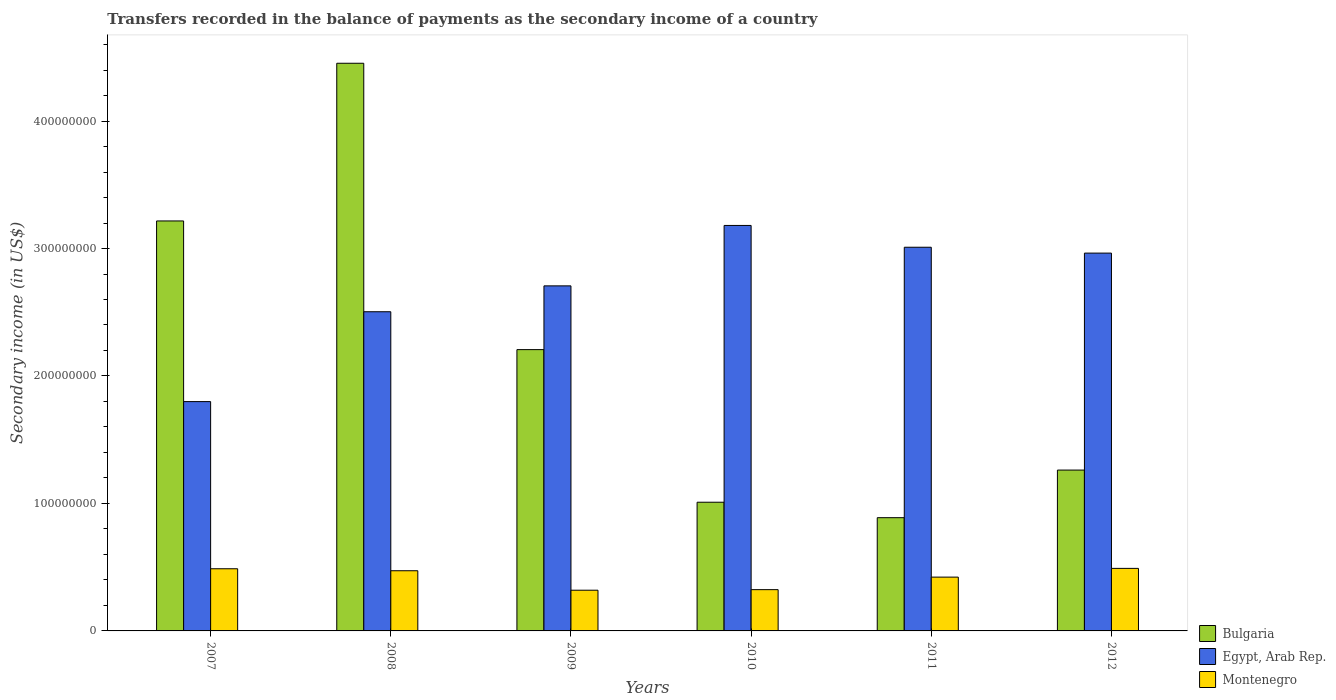How many groups of bars are there?
Provide a short and direct response. 6. Are the number of bars per tick equal to the number of legend labels?
Offer a terse response. Yes. In how many cases, is the number of bars for a given year not equal to the number of legend labels?
Keep it short and to the point. 0. What is the secondary income of in Bulgaria in 2010?
Ensure brevity in your answer.  1.01e+08. Across all years, what is the maximum secondary income of in Montenegro?
Offer a terse response. 4.91e+07. Across all years, what is the minimum secondary income of in Montenegro?
Your answer should be very brief. 3.19e+07. In which year was the secondary income of in Montenegro maximum?
Your answer should be very brief. 2012. In which year was the secondary income of in Montenegro minimum?
Provide a short and direct response. 2009. What is the total secondary income of in Montenegro in the graph?
Your answer should be compact. 2.52e+08. What is the difference between the secondary income of in Montenegro in 2010 and that in 2011?
Keep it short and to the point. -9.83e+06. What is the difference between the secondary income of in Bulgaria in 2007 and the secondary income of in Montenegro in 2010?
Offer a terse response. 2.89e+08. What is the average secondary income of in Egypt, Arab Rep. per year?
Provide a short and direct response. 2.69e+08. In the year 2008, what is the difference between the secondary income of in Egypt, Arab Rep. and secondary income of in Montenegro?
Offer a terse response. 2.03e+08. In how many years, is the secondary income of in Bulgaria greater than 140000000 US$?
Give a very brief answer. 3. What is the ratio of the secondary income of in Egypt, Arab Rep. in 2010 to that in 2011?
Give a very brief answer. 1.06. Is the difference between the secondary income of in Egypt, Arab Rep. in 2008 and 2011 greater than the difference between the secondary income of in Montenegro in 2008 and 2011?
Keep it short and to the point. No. What is the difference between the highest and the second highest secondary income of in Bulgaria?
Ensure brevity in your answer.  1.24e+08. What is the difference between the highest and the lowest secondary income of in Montenegro?
Offer a terse response. 1.71e+07. How many years are there in the graph?
Your answer should be very brief. 6. What is the difference between two consecutive major ticks on the Y-axis?
Your answer should be compact. 1.00e+08. Are the values on the major ticks of Y-axis written in scientific E-notation?
Provide a short and direct response. No. Does the graph contain any zero values?
Offer a terse response. No. Does the graph contain grids?
Your response must be concise. No. Where does the legend appear in the graph?
Your response must be concise. Bottom right. How many legend labels are there?
Provide a succinct answer. 3. What is the title of the graph?
Your response must be concise. Transfers recorded in the balance of payments as the secondary income of a country. What is the label or title of the Y-axis?
Offer a very short reply. Secondary income (in US$). What is the Secondary income (in US$) of Bulgaria in 2007?
Make the answer very short. 3.22e+08. What is the Secondary income (in US$) of Egypt, Arab Rep. in 2007?
Offer a very short reply. 1.80e+08. What is the Secondary income (in US$) of Montenegro in 2007?
Your answer should be compact. 4.88e+07. What is the Secondary income (in US$) of Bulgaria in 2008?
Your response must be concise. 4.45e+08. What is the Secondary income (in US$) of Egypt, Arab Rep. in 2008?
Offer a terse response. 2.50e+08. What is the Secondary income (in US$) of Montenegro in 2008?
Your answer should be compact. 4.72e+07. What is the Secondary income (in US$) of Bulgaria in 2009?
Keep it short and to the point. 2.21e+08. What is the Secondary income (in US$) of Egypt, Arab Rep. in 2009?
Keep it short and to the point. 2.71e+08. What is the Secondary income (in US$) in Montenegro in 2009?
Your response must be concise. 3.19e+07. What is the Secondary income (in US$) of Bulgaria in 2010?
Give a very brief answer. 1.01e+08. What is the Secondary income (in US$) in Egypt, Arab Rep. in 2010?
Keep it short and to the point. 3.18e+08. What is the Secondary income (in US$) in Montenegro in 2010?
Your response must be concise. 3.24e+07. What is the Secondary income (in US$) of Bulgaria in 2011?
Offer a very short reply. 8.88e+07. What is the Secondary income (in US$) in Egypt, Arab Rep. in 2011?
Provide a short and direct response. 3.01e+08. What is the Secondary income (in US$) of Montenegro in 2011?
Give a very brief answer. 4.22e+07. What is the Secondary income (in US$) of Bulgaria in 2012?
Give a very brief answer. 1.26e+08. What is the Secondary income (in US$) of Egypt, Arab Rep. in 2012?
Your answer should be compact. 2.96e+08. What is the Secondary income (in US$) in Montenegro in 2012?
Your answer should be very brief. 4.91e+07. Across all years, what is the maximum Secondary income (in US$) of Bulgaria?
Your answer should be compact. 4.45e+08. Across all years, what is the maximum Secondary income (in US$) of Egypt, Arab Rep.?
Make the answer very short. 3.18e+08. Across all years, what is the maximum Secondary income (in US$) in Montenegro?
Make the answer very short. 4.91e+07. Across all years, what is the minimum Secondary income (in US$) of Bulgaria?
Offer a very short reply. 8.88e+07. Across all years, what is the minimum Secondary income (in US$) in Egypt, Arab Rep.?
Make the answer very short. 1.80e+08. Across all years, what is the minimum Secondary income (in US$) in Montenegro?
Provide a succinct answer. 3.19e+07. What is the total Secondary income (in US$) of Bulgaria in the graph?
Ensure brevity in your answer.  1.30e+09. What is the total Secondary income (in US$) in Egypt, Arab Rep. in the graph?
Keep it short and to the point. 1.62e+09. What is the total Secondary income (in US$) of Montenegro in the graph?
Ensure brevity in your answer.  2.52e+08. What is the difference between the Secondary income (in US$) of Bulgaria in 2007 and that in 2008?
Ensure brevity in your answer.  -1.24e+08. What is the difference between the Secondary income (in US$) of Egypt, Arab Rep. in 2007 and that in 2008?
Make the answer very short. -7.05e+07. What is the difference between the Secondary income (in US$) in Montenegro in 2007 and that in 2008?
Your answer should be very brief. 1.56e+06. What is the difference between the Secondary income (in US$) of Bulgaria in 2007 and that in 2009?
Provide a succinct answer. 1.01e+08. What is the difference between the Secondary income (in US$) of Egypt, Arab Rep. in 2007 and that in 2009?
Your response must be concise. -9.08e+07. What is the difference between the Secondary income (in US$) in Montenegro in 2007 and that in 2009?
Offer a terse response. 1.68e+07. What is the difference between the Secondary income (in US$) of Bulgaria in 2007 and that in 2010?
Offer a very short reply. 2.21e+08. What is the difference between the Secondary income (in US$) in Egypt, Arab Rep. in 2007 and that in 2010?
Keep it short and to the point. -1.38e+08. What is the difference between the Secondary income (in US$) of Montenegro in 2007 and that in 2010?
Offer a very short reply. 1.64e+07. What is the difference between the Secondary income (in US$) in Bulgaria in 2007 and that in 2011?
Offer a very short reply. 2.33e+08. What is the difference between the Secondary income (in US$) of Egypt, Arab Rep. in 2007 and that in 2011?
Offer a very short reply. -1.21e+08. What is the difference between the Secondary income (in US$) of Montenegro in 2007 and that in 2011?
Your answer should be compact. 6.56e+06. What is the difference between the Secondary income (in US$) of Bulgaria in 2007 and that in 2012?
Offer a terse response. 1.95e+08. What is the difference between the Secondary income (in US$) of Egypt, Arab Rep. in 2007 and that in 2012?
Provide a succinct answer. -1.16e+08. What is the difference between the Secondary income (in US$) of Montenegro in 2007 and that in 2012?
Make the answer very short. -2.88e+05. What is the difference between the Secondary income (in US$) in Bulgaria in 2008 and that in 2009?
Offer a terse response. 2.25e+08. What is the difference between the Secondary income (in US$) in Egypt, Arab Rep. in 2008 and that in 2009?
Keep it short and to the point. -2.03e+07. What is the difference between the Secondary income (in US$) of Montenegro in 2008 and that in 2009?
Give a very brief answer. 1.53e+07. What is the difference between the Secondary income (in US$) in Bulgaria in 2008 and that in 2010?
Make the answer very short. 3.44e+08. What is the difference between the Secondary income (in US$) of Egypt, Arab Rep. in 2008 and that in 2010?
Ensure brevity in your answer.  -6.77e+07. What is the difference between the Secondary income (in US$) of Montenegro in 2008 and that in 2010?
Your answer should be compact. 1.48e+07. What is the difference between the Secondary income (in US$) in Bulgaria in 2008 and that in 2011?
Offer a terse response. 3.56e+08. What is the difference between the Secondary income (in US$) in Egypt, Arab Rep. in 2008 and that in 2011?
Keep it short and to the point. -5.06e+07. What is the difference between the Secondary income (in US$) of Montenegro in 2008 and that in 2011?
Provide a succinct answer. 5.01e+06. What is the difference between the Secondary income (in US$) of Bulgaria in 2008 and that in 2012?
Offer a terse response. 3.19e+08. What is the difference between the Secondary income (in US$) of Egypt, Arab Rep. in 2008 and that in 2012?
Give a very brief answer. -4.60e+07. What is the difference between the Secondary income (in US$) of Montenegro in 2008 and that in 2012?
Give a very brief answer. -1.84e+06. What is the difference between the Secondary income (in US$) in Bulgaria in 2009 and that in 2010?
Provide a short and direct response. 1.20e+08. What is the difference between the Secondary income (in US$) in Egypt, Arab Rep. in 2009 and that in 2010?
Make the answer very short. -4.74e+07. What is the difference between the Secondary income (in US$) in Montenegro in 2009 and that in 2010?
Your answer should be compact. -4.32e+05. What is the difference between the Secondary income (in US$) in Bulgaria in 2009 and that in 2011?
Offer a terse response. 1.32e+08. What is the difference between the Secondary income (in US$) of Egypt, Arab Rep. in 2009 and that in 2011?
Your answer should be very brief. -3.03e+07. What is the difference between the Secondary income (in US$) of Montenegro in 2009 and that in 2011?
Ensure brevity in your answer.  -1.03e+07. What is the difference between the Secondary income (in US$) in Bulgaria in 2009 and that in 2012?
Your response must be concise. 9.45e+07. What is the difference between the Secondary income (in US$) in Egypt, Arab Rep. in 2009 and that in 2012?
Give a very brief answer. -2.57e+07. What is the difference between the Secondary income (in US$) in Montenegro in 2009 and that in 2012?
Ensure brevity in your answer.  -1.71e+07. What is the difference between the Secondary income (in US$) in Bulgaria in 2010 and that in 2011?
Provide a short and direct response. 1.21e+07. What is the difference between the Secondary income (in US$) of Egypt, Arab Rep. in 2010 and that in 2011?
Make the answer very short. 1.71e+07. What is the difference between the Secondary income (in US$) in Montenegro in 2010 and that in 2011?
Your answer should be compact. -9.83e+06. What is the difference between the Secondary income (in US$) in Bulgaria in 2010 and that in 2012?
Your answer should be very brief. -2.52e+07. What is the difference between the Secondary income (in US$) in Egypt, Arab Rep. in 2010 and that in 2012?
Give a very brief answer. 2.17e+07. What is the difference between the Secondary income (in US$) of Montenegro in 2010 and that in 2012?
Make the answer very short. -1.67e+07. What is the difference between the Secondary income (in US$) of Bulgaria in 2011 and that in 2012?
Give a very brief answer. -3.73e+07. What is the difference between the Secondary income (in US$) of Egypt, Arab Rep. in 2011 and that in 2012?
Your answer should be very brief. 4.60e+06. What is the difference between the Secondary income (in US$) in Montenegro in 2011 and that in 2012?
Give a very brief answer. -6.85e+06. What is the difference between the Secondary income (in US$) of Bulgaria in 2007 and the Secondary income (in US$) of Egypt, Arab Rep. in 2008?
Give a very brief answer. 7.12e+07. What is the difference between the Secondary income (in US$) of Bulgaria in 2007 and the Secondary income (in US$) of Montenegro in 2008?
Provide a short and direct response. 2.74e+08. What is the difference between the Secondary income (in US$) in Egypt, Arab Rep. in 2007 and the Secondary income (in US$) in Montenegro in 2008?
Ensure brevity in your answer.  1.33e+08. What is the difference between the Secondary income (in US$) in Bulgaria in 2007 and the Secondary income (in US$) in Egypt, Arab Rep. in 2009?
Give a very brief answer. 5.09e+07. What is the difference between the Secondary income (in US$) in Bulgaria in 2007 and the Secondary income (in US$) in Montenegro in 2009?
Offer a terse response. 2.90e+08. What is the difference between the Secondary income (in US$) of Egypt, Arab Rep. in 2007 and the Secondary income (in US$) of Montenegro in 2009?
Ensure brevity in your answer.  1.48e+08. What is the difference between the Secondary income (in US$) of Bulgaria in 2007 and the Secondary income (in US$) of Egypt, Arab Rep. in 2010?
Give a very brief answer. 3.53e+06. What is the difference between the Secondary income (in US$) of Bulgaria in 2007 and the Secondary income (in US$) of Montenegro in 2010?
Your answer should be very brief. 2.89e+08. What is the difference between the Secondary income (in US$) in Egypt, Arab Rep. in 2007 and the Secondary income (in US$) in Montenegro in 2010?
Your answer should be compact. 1.48e+08. What is the difference between the Secondary income (in US$) in Bulgaria in 2007 and the Secondary income (in US$) in Egypt, Arab Rep. in 2011?
Offer a very short reply. 2.06e+07. What is the difference between the Secondary income (in US$) of Bulgaria in 2007 and the Secondary income (in US$) of Montenegro in 2011?
Offer a terse response. 2.79e+08. What is the difference between the Secondary income (in US$) in Egypt, Arab Rep. in 2007 and the Secondary income (in US$) in Montenegro in 2011?
Offer a terse response. 1.38e+08. What is the difference between the Secondary income (in US$) in Bulgaria in 2007 and the Secondary income (in US$) in Egypt, Arab Rep. in 2012?
Your answer should be very brief. 2.52e+07. What is the difference between the Secondary income (in US$) in Bulgaria in 2007 and the Secondary income (in US$) in Montenegro in 2012?
Provide a succinct answer. 2.73e+08. What is the difference between the Secondary income (in US$) of Egypt, Arab Rep. in 2007 and the Secondary income (in US$) of Montenegro in 2012?
Your answer should be very brief. 1.31e+08. What is the difference between the Secondary income (in US$) of Bulgaria in 2008 and the Secondary income (in US$) of Egypt, Arab Rep. in 2009?
Your answer should be compact. 1.75e+08. What is the difference between the Secondary income (in US$) of Bulgaria in 2008 and the Secondary income (in US$) of Montenegro in 2009?
Your answer should be compact. 4.13e+08. What is the difference between the Secondary income (in US$) of Egypt, Arab Rep. in 2008 and the Secondary income (in US$) of Montenegro in 2009?
Your answer should be very brief. 2.18e+08. What is the difference between the Secondary income (in US$) in Bulgaria in 2008 and the Secondary income (in US$) in Egypt, Arab Rep. in 2010?
Ensure brevity in your answer.  1.27e+08. What is the difference between the Secondary income (in US$) of Bulgaria in 2008 and the Secondary income (in US$) of Montenegro in 2010?
Your response must be concise. 4.13e+08. What is the difference between the Secondary income (in US$) of Egypt, Arab Rep. in 2008 and the Secondary income (in US$) of Montenegro in 2010?
Offer a terse response. 2.18e+08. What is the difference between the Secondary income (in US$) in Bulgaria in 2008 and the Secondary income (in US$) in Egypt, Arab Rep. in 2011?
Provide a short and direct response. 1.44e+08. What is the difference between the Secondary income (in US$) in Bulgaria in 2008 and the Secondary income (in US$) in Montenegro in 2011?
Your response must be concise. 4.03e+08. What is the difference between the Secondary income (in US$) in Egypt, Arab Rep. in 2008 and the Secondary income (in US$) in Montenegro in 2011?
Provide a short and direct response. 2.08e+08. What is the difference between the Secondary income (in US$) in Bulgaria in 2008 and the Secondary income (in US$) in Egypt, Arab Rep. in 2012?
Make the answer very short. 1.49e+08. What is the difference between the Secondary income (in US$) in Bulgaria in 2008 and the Secondary income (in US$) in Montenegro in 2012?
Your answer should be compact. 3.96e+08. What is the difference between the Secondary income (in US$) in Egypt, Arab Rep. in 2008 and the Secondary income (in US$) in Montenegro in 2012?
Your answer should be very brief. 2.01e+08. What is the difference between the Secondary income (in US$) in Bulgaria in 2009 and the Secondary income (in US$) in Egypt, Arab Rep. in 2010?
Your response must be concise. -9.74e+07. What is the difference between the Secondary income (in US$) in Bulgaria in 2009 and the Secondary income (in US$) in Montenegro in 2010?
Offer a terse response. 1.88e+08. What is the difference between the Secondary income (in US$) in Egypt, Arab Rep. in 2009 and the Secondary income (in US$) in Montenegro in 2010?
Your answer should be compact. 2.38e+08. What is the difference between the Secondary income (in US$) of Bulgaria in 2009 and the Secondary income (in US$) of Egypt, Arab Rep. in 2011?
Your response must be concise. -8.03e+07. What is the difference between the Secondary income (in US$) in Bulgaria in 2009 and the Secondary income (in US$) in Montenegro in 2011?
Provide a short and direct response. 1.78e+08. What is the difference between the Secondary income (in US$) in Egypt, Arab Rep. in 2009 and the Secondary income (in US$) in Montenegro in 2011?
Ensure brevity in your answer.  2.28e+08. What is the difference between the Secondary income (in US$) in Bulgaria in 2009 and the Secondary income (in US$) in Egypt, Arab Rep. in 2012?
Offer a terse response. -7.57e+07. What is the difference between the Secondary income (in US$) of Bulgaria in 2009 and the Secondary income (in US$) of Montenegro in 2012?
Offer a very short reply. 1.72e+08. What is the difference between the Secondary income (in US$) in Egypt, Arab Rep. in 2009 and the Secondary income (in US$) in Montenegro in 2012?
Ensure brevity in your answer.  2.22e+08. What is the difference between the Secondary income (in US$) in Bulgaria in 2010 and the Secondary income (in US$) in Egypt, Arab Rep. in 2011?
Keep it short and to the point. -2.00e+08. What is the difference between the Secondary income (in US$) in Bulgaria in 2010 and the Secondary income (in US$) in Montenegro in 2011?
Your answer should be compact. 5.87e+07. What is the difference between the Secondary income (in US$) in Egypt, Arab Rep. in 2010 and the Secondary income (in US$) in Montenegro in 2011?
Your response must be concise. 2.76e+08. What is the difference between the Secondary income (in US$) of Bulgaria in 2010 and the Secondary income (in US$) of Egypt, Arab Rep. in 2012?
Offer a terse response. -1.95e+08. What is the difference between the Secondary income (in US$) in Bulgaria in 2010 and the Secondary income (in US$) in Montenegro in 2012?
Your answer should be very brief. 5.19e+07. What is the difference between the Secondary income (in US$) of Egypt, Arab Rep. in 2010 and the Secondary income (in US$) of Montenegro in 2012?
Your answer should be very brief. 2.69e+08. What is the difference between the Secondary income (in US$) in Bulgaria in 2011 and the Secondary income (in US$) in Egypt, Arab Rep. in 2012?
Give a very brief answer. -2.08e+08. What is the difference between the Secondary income (in US$) in Bulgaria in 2011 and the Secondary income (in US$) in Montenegro in 2012?
Your answer should be very brief. 3.98e+07. What is the difference between the Secondary income (in US$) in Egypt, Arab Rep. in 2011 and the Secondary income (in US$) in Montenegro in 2012?
Give a very brief answer. 2.52e+08. What is the average Secondary income (in US$) of Bulgaria per year?
Offer a terse response. 2.17e+08. What is the average Secondary income (in US$) of Egypt, Arab Rep. per year?
Make the answer very short. 2.69e+08. What is the average Secondary income (in US$) of Montenegro per year?
Your answer should be compact. 4.19e+07. In the year 2007, what is the difference between the Secondary income (in US$) of Bulgaria and Secondary income (in US$) of Egypt, Arab Rep.?
Offer a very short reply. 1.42e+08. In the year 2007, what is the difference between the Secondary income (in US$) in Bulgaria and Secondary income (in US$) in Montenegro?
Give a very brief answer. 2.73e+08. In the year 2007, what is the difference between the Secondary income (in US$) of Egypt, Arab Rep. and Secondary income (in US$) of Montenegro?
Ensure brevity in your answer.  1.31e+08. In the year 2008, what is the difference between the Secondary income (in US$) in Bulgaria and Secondary income (in US$) in Egypt, Arab Rep.?
Your answer should be compact. 1.95e+08. In the year 2008, what is the difference between the Secondary income (in US$) of Bulgaria and Secondary income (in US$) of Montenegro?
Ensure brevity in your answer.  3.98e+08. In the year 2008, what is the difference between the Secondary income (in US$) of Egypt, Arab Rep. and Secondary income (in US$) of Montenegro?
Your response must be concise. 2.03e+08. In the year 2009, what is the difference between the Secondary income (in US$) of Bulgaria and Secondary income (in US$) of Egypt, Arab Rep.?
Make the answer very short. -5.00e+07. In the year 2009, what is the difference between the Secondary income (in US$) in Bulgaria and Secondary income (in US$) in Montenegro?
Your answer should be very brief. 1.89e+08. In the year 2009, what is the difference between the Secondary income (in US$) in Egypt, Arab Rep. and Secondary income (in US$) in Montenegro?
Offer a terse response. 2.39e+08. In the year 2010, what is the difference between the Secondary income (in US$) of Bulgaria and Secondary income (in US$) of Egypt, Arab Rep.?
Provide a short and direct response. -2.17e+08. In the year 2010, what is the difference between the Secondary income (in US$) in Bulgaria and Secondary income (in US$) in Montenegro?
Provide a short and direct response. 6.86e+07. In the year 2010, what is the difference between the Secondary income (in US$) of Egypt, Arab Rep. and Secondary income (in US$) of Montenegro?
Your response must be concise. 2.86e+08. In the year 2011, what is the difference between the Secondary income (in US$) in Bulgaria and Secondary income (in US$) in Egypt, Arab Rep.?
Ensure brevity in your answer.  -2.12e+08. In the year 2011, what is the difference between the Secondary income (in US$) in Bulgaria and Secondary income (in US$) in Montenegro?
Provide a short and direct response. 4.66e+07. In the year 2011, what is the difference between the Secondary income (in US$) of Egypt, Arab Rep. and Secondary income (in US$) of Montenegro?
Keep it short and to the point. 2.59e+08. In the year 2012, what is the difference between the Secondary income (in US$) in Bulgaria and Secondary income (in US$) in Egypt, Arab Rep.?
Provide a short and direct response. -1.70e+08. In the year 2012, what is the difference between the Secondary income (in US$) in Bulgaria and Secondary income (in US$) in Montenegro?
Provide a short and direct response. 7.71e+07. In the year 2012, what is the difference between the Secondary income (in US$) in Egypt, Arab Rep. and Secondary income (in US$) in Montenegro?
Offer a terse response. 2.47e+08. What is the ratio of the Secondary income (in US$) of Bulgaria in 2007 to that in 2008?
Your answer should be very brief. 0.72. What is the ratio of the Secondary income (in US$) of Egypt, Arab Rep. in 2007 to that in 2008?
Offer a very short reply. 0.72. What is the ratio of the Secondary income (in US$) in Montenegro in 2007 to that in 2008?
Provide a short and direct response. 1.03. What is the ratio of the Secondary income (in US$) in Bulgaria in 2007 to that in 2009?
Your answer should be very brief. 1.46. What is the ratio of the Secondary income (in US$) of Egypt, Arab Rep. in 2007 to that in 2009?
Your answer should be compact. 0.66. What is the ratio of the Secondary income (in US$) of Montenegro in 2007 to that in 2009?
Offer a terse response. 1.53. What is the ratio of the Secondary income (in US$) in Bulgaria in 2007 to that in 2010?
Your response must be concise. 3.19. What is the ratio of the Secondary income (in US$) in Egypt, Arab Rep. in 2007 to that in 2010?
Your response must be concise. 0.57. What is the ratio of the Secondary income (in US$) of Montenegro in 2007 to that in 2010?
Your answer should be compact. 1.51. What is the ratio of the Secondary income (in US$) of Bulgaria in 2007 to that in 2011?
Provide a succinct answer. 3.62. What is the ratio of the Secondary income (in US$) of Egypt, Arab Rep. in 2007 to that in 2011?
Offer a very short reply. 0.6. What is the ratio of the Secondary income (in US$) in Montenegro in 2007 to that in 2011?
Your response must be concise. 1.16. What is the ratio of the Secondary income (in US$) of Bulgaria in 2007 to that in 2012?
Your answer should be compact. 2.55. What is the ratio of the Secondary income (in US$) in Egypt, Arab Rep. in 2007 to that in 2012?
Offer a very short reply. 0.61. What is the ratio of the Secondary income (in US$) of Bulgaria in 2008 to that in 2009?
Provide a succinct answer. 2.02. What is the ratio of the Secondary income (in US$) in Egypt, Arab Rep. in 2008 to that in 2009?
Provide a short and direct response. 0.93. What is the ratio of the Secondary income (in US$) of Montenegro in 2008 to that in 2009?
Make the answer very short. 1.48. What is the ratio of the Secondary income (in US$) in Bulgaria in 2008 to that in 2010?
Your answer should be very brief. 4.41. What is the ratio of the Secondary income (in US$) in Egypt, Arab Rep. in 2008 to that in 2010?
Make the answer very short. 0.79. What is the ratio of the Secondary income (in US$) in Montenegro in 2008 to that in 2010?
Your answer should be very brief. 1.46. What is the ratio of the Secondary income (in US$) in Bulgaria in 2008 to that in 2011?
Ensure brevity in your answer.  5.01. What is the ratio of the Secondary income (in US$) in Egypt, Arab Rep. in 2008 to that in 2011?
Keep it short and to the point. 0.83. What is the ratio of the Secondary income (in US$) of Montenegro in 2008 to that in 2011?
Provide a short and direct response. 1.12. What is the ratio of the Secondary income (in US$) of Bulgaria in 2008 to that in 2012?
Make the answer very short. 3.53. What is the ratio of the Secondary income (in US$) of Egypt, Arab Rep. in 2008 to that in 2012?
Keep it short and to the point. 0.84. What is the ratio of the Secondary income (in US$) of Montenegro in 2008 to that in 2012?
Give a very brief answer. 0.96. What is the ratio of the Secondary income (in US$) in Bulgaria in 2009 to that in 2010?
Provide a succinct answer. 2.19. What is the ratio of the Secondary income (in US$) of Egypt, Arab Rep. in 2009 to that in 2010?
Offer a terse response. 0.85. What is the ratio of the Secondary income (in US$) in Montenegro in 2009 to that in 2010?
Your response must be concise. 0.99. What is the ratio of the Secondary income (in US$) in Bulgaria in 2009 to that in 2011?
Offer a very short reply. 2.48. What is the ratio of the Secondary income (in US$) of Egypt, Arab Rep. in 2009 to that in 2011?
Your answer should be very brief. 0.9. What is the ratio of the Secondary income (in US$) of Montenegro in 2009 to that in 2011?
Offer a terse response. 0.76. What is the ratio of the Secondary income (in US$) of Bulgaria in 2009 to that in 2012?
Provide a succinct answer. 1.75. What is the ratio of the Secondary income (in US$) of Egypt, Arab Rep. in 2009 to that in 2012?
Make the answer very short. 0.91. What is the ratio of the Secondary income (in US$) in Montenegro in 2009 to that in 2012?
Keep it short and to the point. 0.65. What is the ratio of the Secondary income (in US$) of Bulgaria in 2010 to that in 2011?
Offer a very short reply. 1.14. What is the ratio of the Secondary income (in US$) of Egypt, Arab Rep. in 2010 to that in 2011?
Provide a short and direct response. 1.06. What is the ratio of the Secondary income (in US$) in Montenegro in 2010 to that in 2011?
Ensure brevity in your answer.  0.77. What is the ratio of the Secondary income (in US$) in Egypt, Arab Rep. in 2010 to that in 2012?
Ensure brevity in your answer.  1.07. What is the ratio of the Secondary income (in US$) in Montenegro in 2010 to that in 2012?
Keep it short and to the point. 0.66. What is the ratio of the Secondary income (in US$) in Bulgaria in 2011 to that in 2012?
Keep it short and to the point. 0.7. What is the ratio of the Secondary income (in US$) of Egypt, Arab Rep. in 2011 to that in 2012?
Provide a short and direct response. 1.02. What is the ratio of the Secondary income (in US$) in Montenegro in 2011 to that in 2012?
Ensure brevity in your answer.  0.86. What is the difference between the highest and the second highest Secondary income (in US$) in Bulgaria?
Offer a very short reply. 1.24e+08. What is the difference between the highest and the second highest Secondary income (in US$) of Egypt, Arab Rep.?
Ensure brevity in your answer.  1.71e+07. What is the difference between the highest and the second highest Secondary income (in US$) in Montenegro?
Give a very brief answer. 2.88e+05. What is the difference between the highest and the lowest Secondary income (in US$) in Bulgaria?
Your response must be concise. 3.56e+08. What is the difference between the highest and the lowest Secondary income (in US$) in Egypt, Arab Rep.?
Keep it short and to the point. 1.38e+08. What is the difference between the highest and the lowest Secondary income (in US$) in Montenegro?
Make the answer very short. 1.71e+07. 